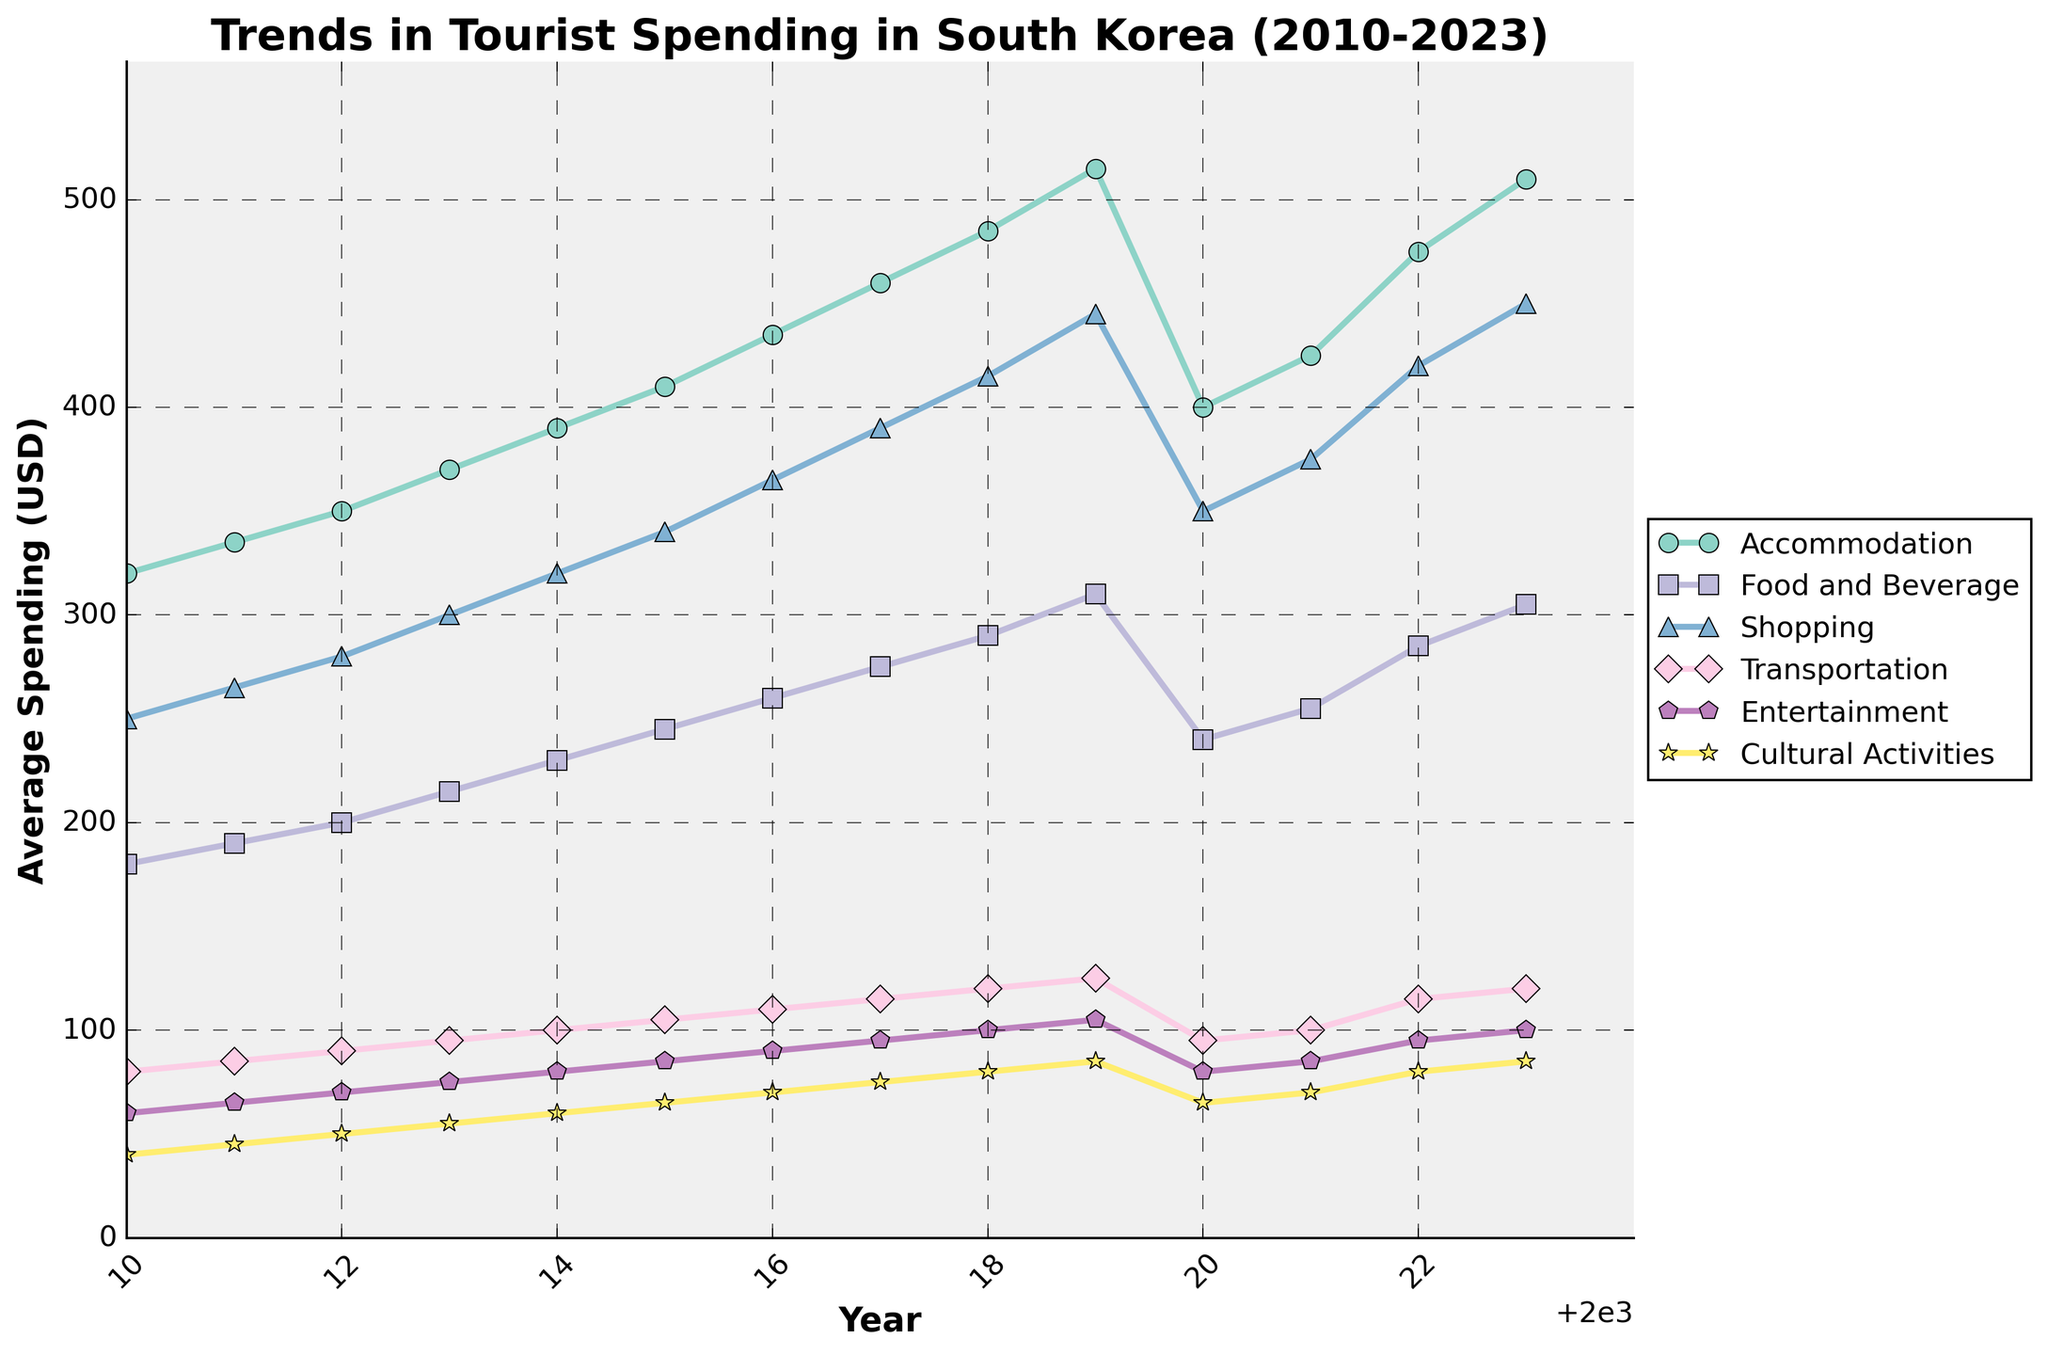What is the overall trend in average spending on Accommodation from 2010 to 2023? The line representing Accommodation shows a general upward trend from 320 USD in 2010 to 510 USD in 2023, with a dip in 2020 due to the Covid-19 pandemic.
Answer: Upward Which type of expenditure increased the most between 2010 and 2023? To find the type of expenditure that increased the most, calculate the difference for each category between 2023 and 2010. Accommodation increased by 190 USD, Food and Beverage by 125 USD, Shopping by 200 USD, Transportation by 40 USD, Entertainment by 40 USD, and Cultural Activities by 45 USD. Shopping has the highest increase.
Answer: Shopping In which year did Tourist's overall spending on Cultural Activities surpass 70 USD for the first time? The line for Cultural Activities crosses 70 USD in 2016.
Answer: 2016 How did the average spending on Transportation change during the Covid-19 pandemic years (2020-2021)? Between 2020 and 2021, the average spending on Transportation slightly increased from 95 USD to 100 USD.
Answer: Increased Compare the spending on Accommodation and Shopping in 2022. Which was higher and by how much? In 2022, the spending on Accommodation was 475 USD, and on Shopping was 420 USD. The difference is 475 - 420 = 55 USD.
Answer: Accommodation by 55 USD Which category had the least spending in 2023, and what was the amount? Cultural Activities had the least spending in 2023, which is 85 USD.
Answer: Cultural Activities, 85 USD What was the percentage increase in average spending on Entertainment from 2010 to 2023? To find the percentage increase, use the formula: ((final value - initial value)/initial value) * 100. For Entertainment, it is ((100 - 60)/60) * 100 = 66.67%.
Answer: 66.67% If the trend in Food and Beverage continues, what would the projected spending be in 2024? Looking at the increase from 2022 to 2023, which is 305 - 285 = 20 USD, assuming the same increase, the projected spending in 2024 would be 305 + 20 = 325 USD.
Answer: 325 USD By how much did the average spending on Shopping and Food and Beverage together exceed the spending on Accommodation in 2019? In 2019, Shopping was 445 USD and Food and Beverage was 310 USD. Together, they are 445 + 310 = 755 USD. Accommodation was 515 USD. The difference is 755 - 515 = 240 USD.
Answer: 240 USD Between which consecutive years did the spending on Accommodation see the highest increase? To find the highest increase, calculate the differences year by year. The highest increase is between 2022 and 2023, which is 510 - 475 = 35 USD.
Answer: 2022-2023 